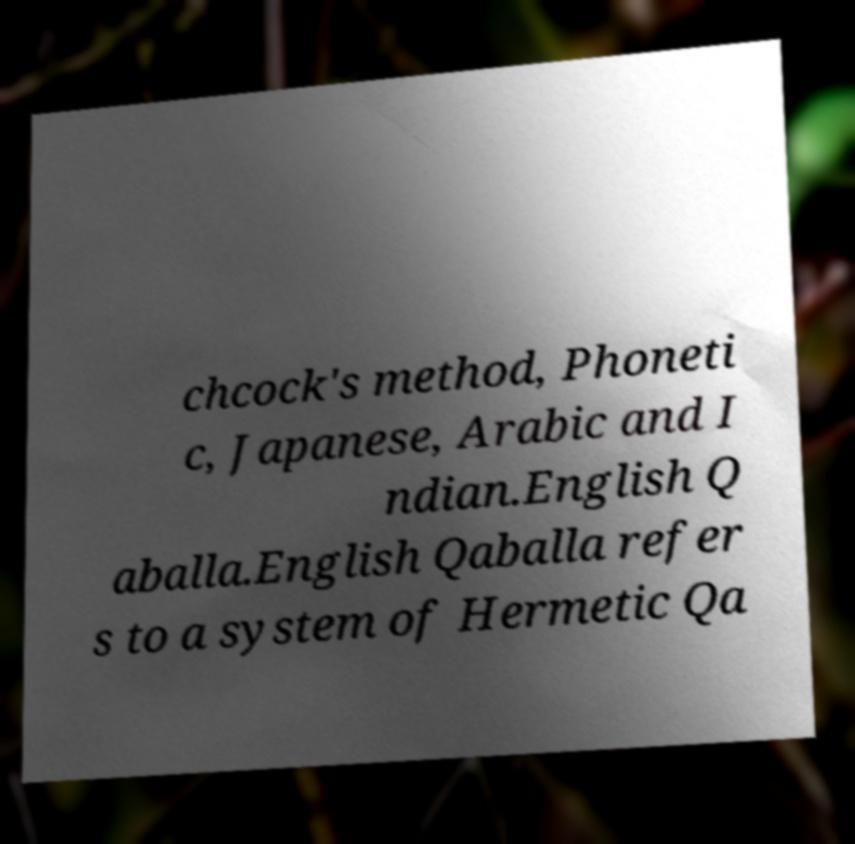Could you assist in decoding the text presented in this image and type it out clearly? chcock's method, Phoneti c, Japanese, Arabic and I ndian.English Q aballa.English Qaballa refer s to a system of Hermetic Qa 